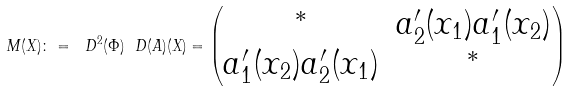Convert formula to latex. <formula><loc_0><loc_0><loc_500><loc_500>M ( X ) \colon = \ D ^ { 2 } ( \Phi ) \ D ( A ) ( X ) = \begin{pmatrix} ^ { * } & a _ { 2 } ^ { \prime } ( x _ { 1 } ) a _ { 1 } ^ { \prime } ( x _ { 2 } ) \\ a _ { 1 } ^ { \prime } ( x _ { 2 } ) a _ { 2 } ^ { \prime } ( x _ { 1 } ) & ^ { * } \end{pmatrix}</formula> 